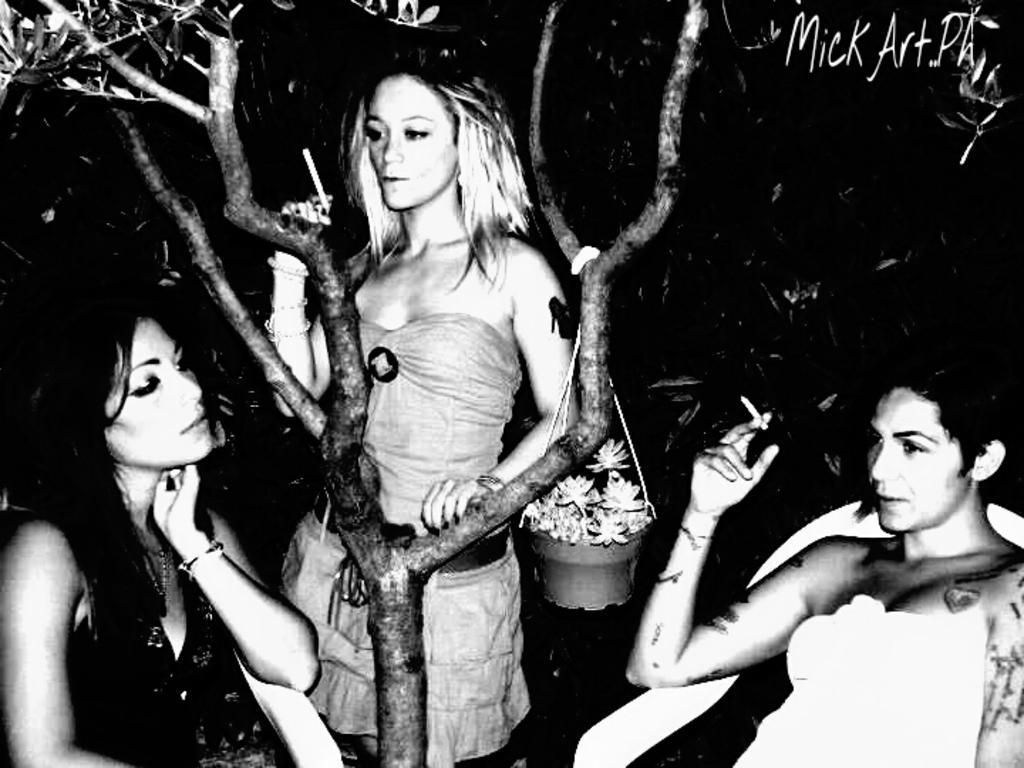Describe this image in one or two sentences. Here in this picture we can see two women sitting on chairs and in between them we can see a woman standing and in front of her we can see a tree present and on that tree we can see a bucket of flowers hanging and all of them are carrying cigarettes in their hands and this is a black and white image. 